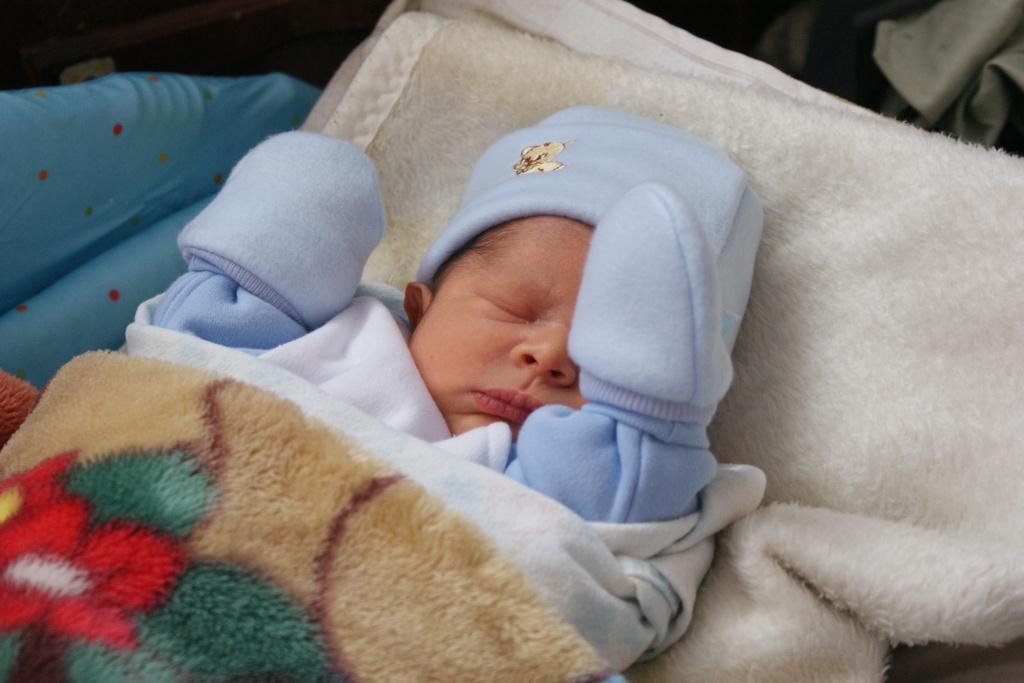Could you give a brief overview of what you see in this image? In this picture we can see a little baby wearing a blue dress and sleeping on a white towel covered with a blanket. 